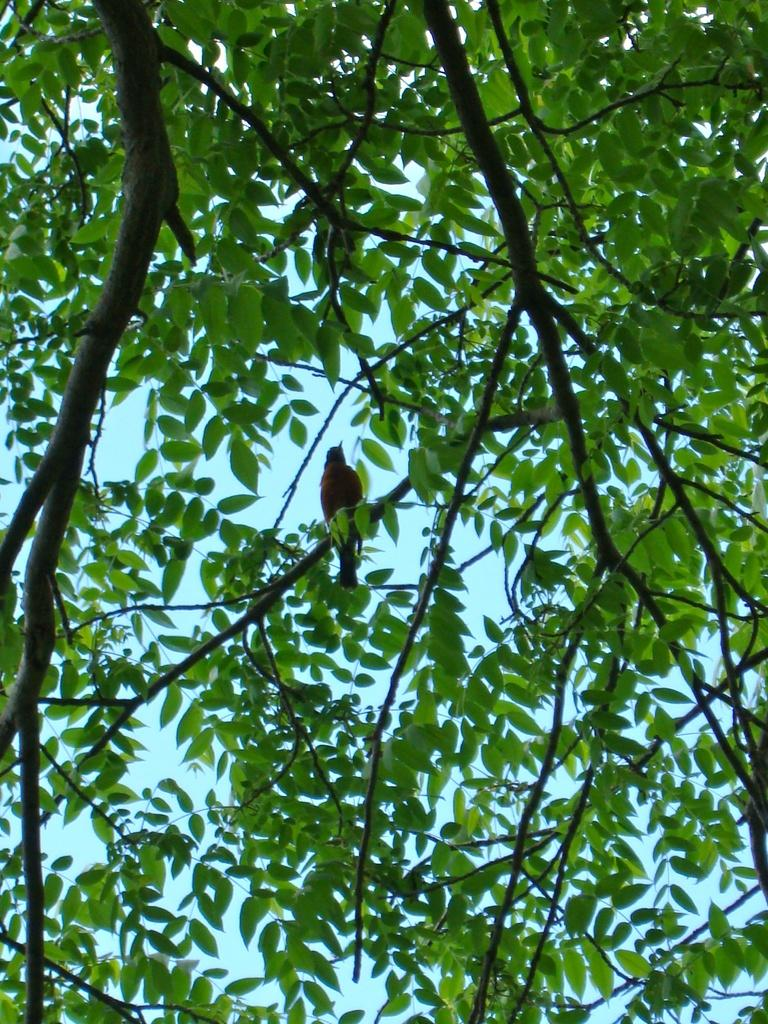What type of animal can be seen in the image? There is a bird in the image. Where is the bird located in the image? The bird is on a tree branch. What type of bit is the bird using to eat the eggnog in the image? There is no bit or eggnog present in the image; it features a bird on a tree branch. 